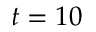Convert formula to latex. <formula><loc_0><loc_0><loc_500><loc_500>t = 1 0</formula> 